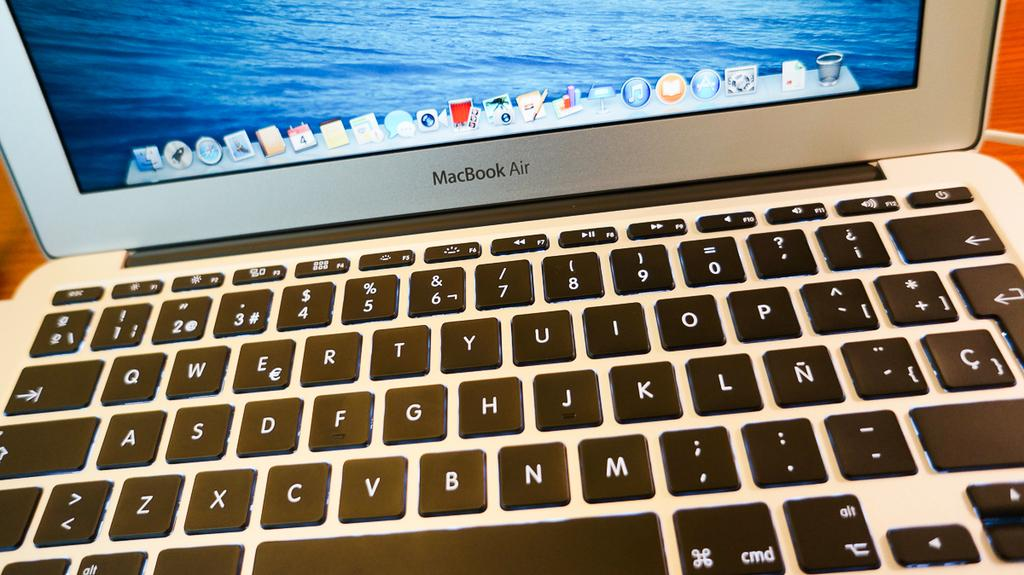Provide a one-sentence caption for the provided image. A closeup of the keyboard on a MacBook Air. 